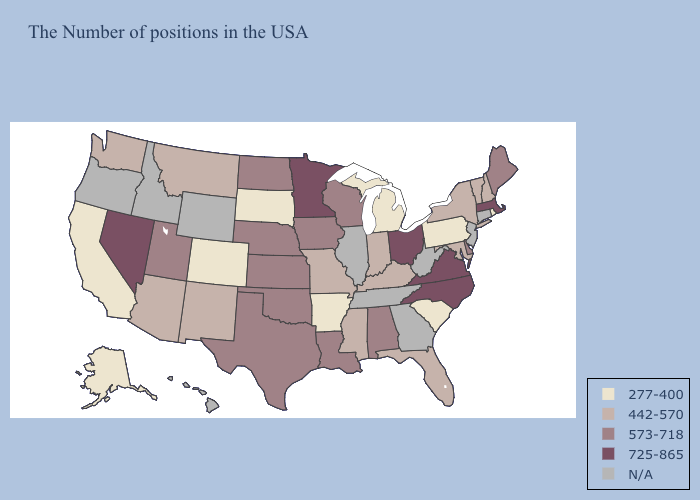What is the highest value in the West ?
Quick response, please. 725-865. Name the states that have a value in the range 573-718?
Write a very short answer. Maine, Delaware, Alabama, Wisconsin, Louisiana, Iowa, Kansas, Nebraska, Oklahoma, Texas, North Dakota, Utah. Name the states that have a value in the range 725-865?
Quick response, please. Massachusetts, Virginia, North Carolina, Ohio, Minnesota, Nevada. What is the highest value in the Northeast ?
Short answer required. 725-865. How many symbols are there in the legend?
Short answer required. 5. What is the highest value in the West ?
Write a very short answer. 725-865. What is the lowest value in the USA?
Be succinct. 277-400. Name the states that have a value in the range N/A?
Be succinct. Connecticut, New Jersey, West Virginia, Georgia, Tennessee, Illinois, Wyoming, Idaho, Oregon, Hawaii. Among the states that border New Hampshire , does Vermont have the lowest value?
Keep it brief. Yes. Among the states that border West Virginia , which have the highest value?
Answer briefly. Virginia, Ohio. Does the map have missing data?
Write a very short answer. Yes. What is the value of Idaho?
Keep it brief. N/A. What is the value of Wyoming?
Keep it brief. N/A. Name the states that have a value in the range 725-865?
Write a very short answer. Massachusetts, Virginia, North Carolina, Ohio, Minnesota, Nevada. 